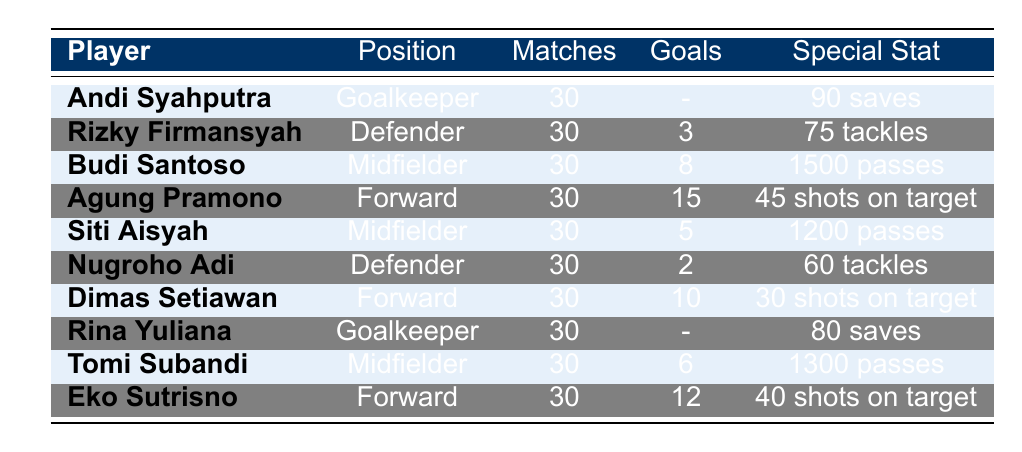What is the total number of goals scored by all forwards? The forwards in the table are Agung Pramono, Dimas Setiawan, and Eko Sutrisno. Their goals scored are 15, 10, and 12 respectively. To find the total, add these values: 15 + 10 + 12 = 37.
Answer: 37 How many clean sheets did Andi Syahputra have? Referencing the table, Andi Syahputra, who is a goalkeeper, has 12 clean sheets listed in the "Special Stat" column.
Answer: 12 Which player had the highest number of assists? Budi Santoso has the highest number of assists with 10, compared to the other players' assists listed in the table.
Answer: Budi Santoso Did any defender score more than 3 goals? Checking the goals scored by defenders, Rizky Firmansyah scored 3 goals and Nugroho Adi scored 2 goals, neither scored more than 3.
Answer: No What is the average number of goals scored by all midfielders? The midfielders are Budi Santoso with 8 goals, Siti Aisyah with 5 goals, and Tomi Subandi with 6 goals. The sum of their goals is 8 + 5 + 6 = 19. Since there are 3 midfielders, the average is 19 / 3, which equals approximately 6.33.
Answer: 6.33 How many saves did Rina Yuliana make? Rina Yuliana, who is also a goalkeeper, has 80 saves recorded in the "Special Stat" column of the table.
Answer: 80 Which position had the least goals scored? The defenders had the lowest total goals scored. Rizky Firmansyah scored 3 and Nugroho Adi scored 2, totaling only 5 goals. Midfielders and forwards scored significantly more.
Answer: Defender Is the total number of tackles by defenders more than 100? The tackles by Rizky Firmansyah are 75 and by Nugroho Adi are 60. Adding these gives 75 + 60 = 135, which is greater than 100.
Answer: Yes What percentage of matches did Agung Pramono score in? Agung Pramono scored 15 goals in 30 matches. To find the percentage of matches he scored in, calculate (15 / 30) * 100 = 50%.
Answer: 50% 